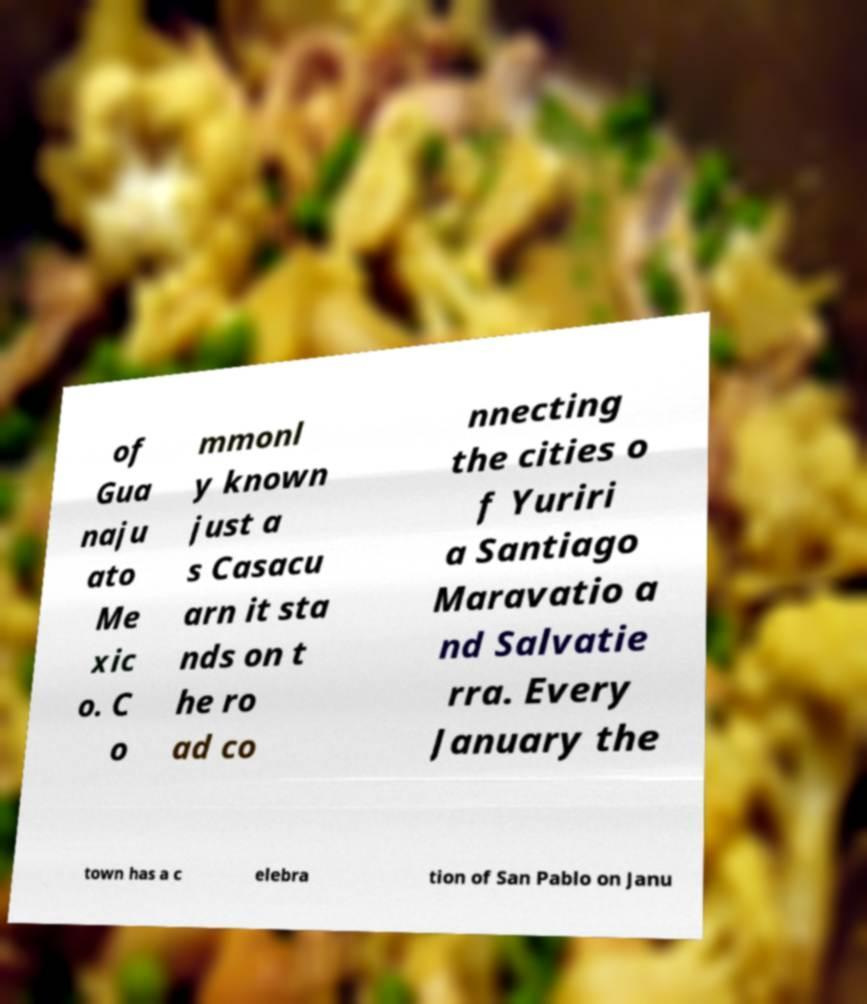What messages or text are displayed in this image? I need them in a readable, typed format. of Gua naju ato Me xic o. C o mmonl y known just a s Casacu arn it sta nds on t he ro ad co nnecting the cities o f Yuriri a Santiago Maravatio a nd Salvatie rra. Every January the town has a c elebra tion of San Pablo on Janu 